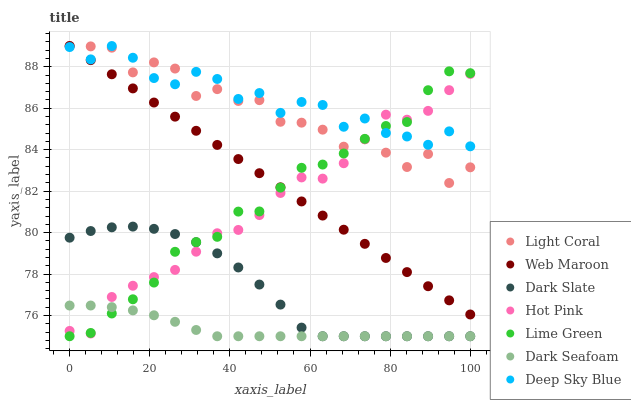Does Dark Seafoam have the minimum area under the curve?
Answer yes or no. Yes. Does Deep Sky Blue have the maximum area under the curve?
Answer yes or no. Yes. Does Web Maroon have the minimum area under the curve?
Answer yes or no. No. Does Web Maroon have the maximum area under the curve?
Answer yes or no. No. Is Web Maroon the smoothest?
Answer yes or no. Yes. Is Light Coral the roughest?
Answer yes or no. Yes. Is Light Coral the smoothest?
Answer yes or no. No. Is Web Maroon the roughest?
Answer yes or no. No. Does Dark Slate have the lowest value?
Answer yes or no. Yes. Does Web Maroon have the lowest value?
Answer yes or no. No. Does Deep Sky Blue have the highest value?
Answer yes or no. Yes. Does Dark Slate have the highest value?
Answer yes or no. No. Is Dark Slate less than Deep Sky Blue?
Answer yes or no. Yes. Is Deep Sky Blue greater than Dark Seafoam?
Answer yes or no. Yes. Does Hot Pink intersect Deep Sky Blue?
Answer yes or no. Yes. Is Hot Pink less than Deep Sky Blue?
Answer yes or no. No. Is Hot Pink greater than Deep Sky Blue?
Answer yes or no. No. Does Dark Slate intersect Deep Sky Blue?
Answer yes or no. No. 